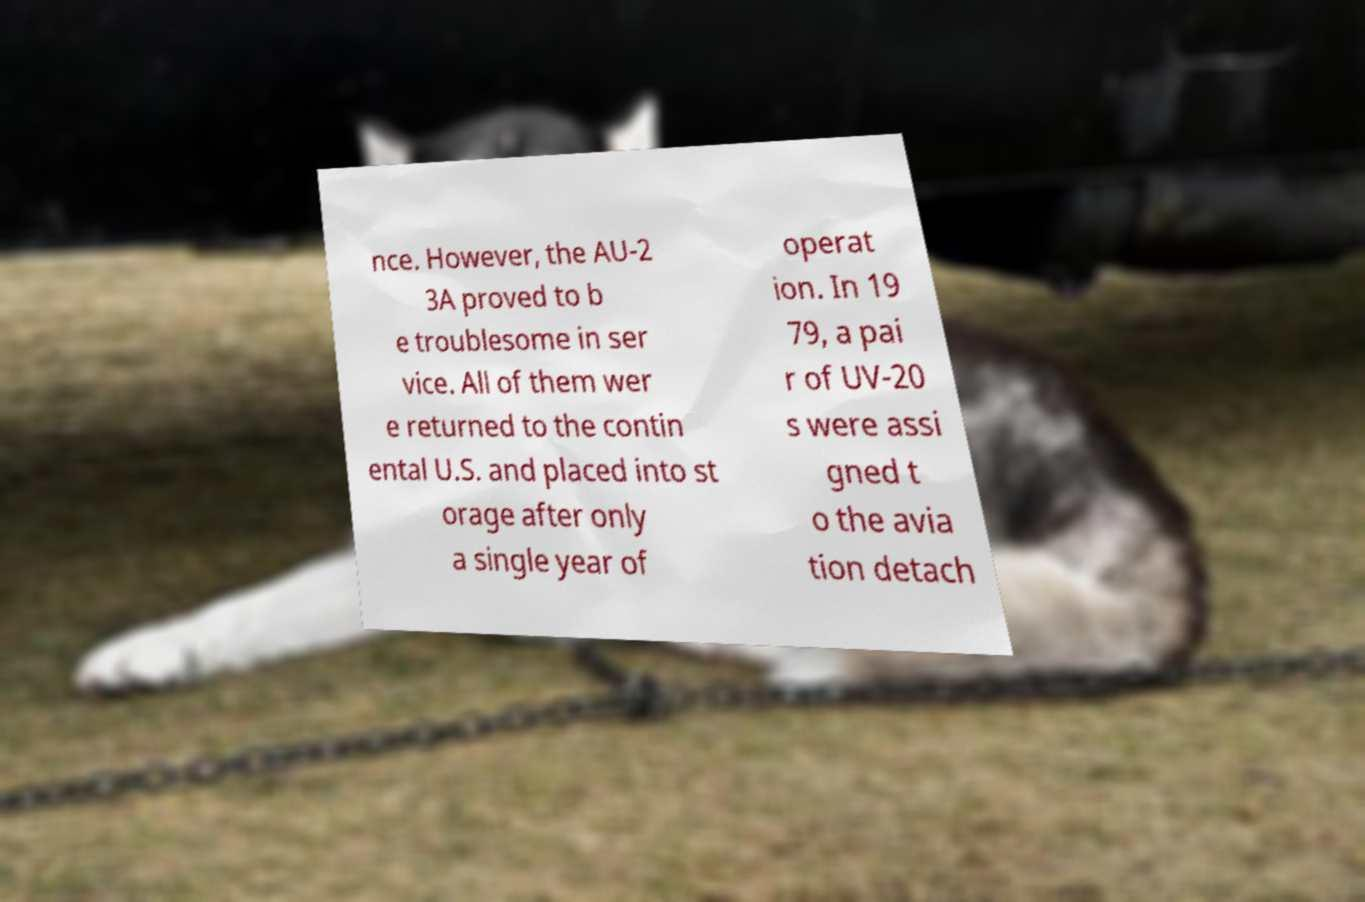There's text embedded in this image that I need extracted. Can you transcribe it verbatim? nce. However, the AU-2 3A proved to b e troublesome in ser vice. All of them wer e returned to the contin ental U.S. and placed into st orage after only a single year of operat ion. In 19 79, a pai r of UV-20 s were assi gned t o the avia tion detach 